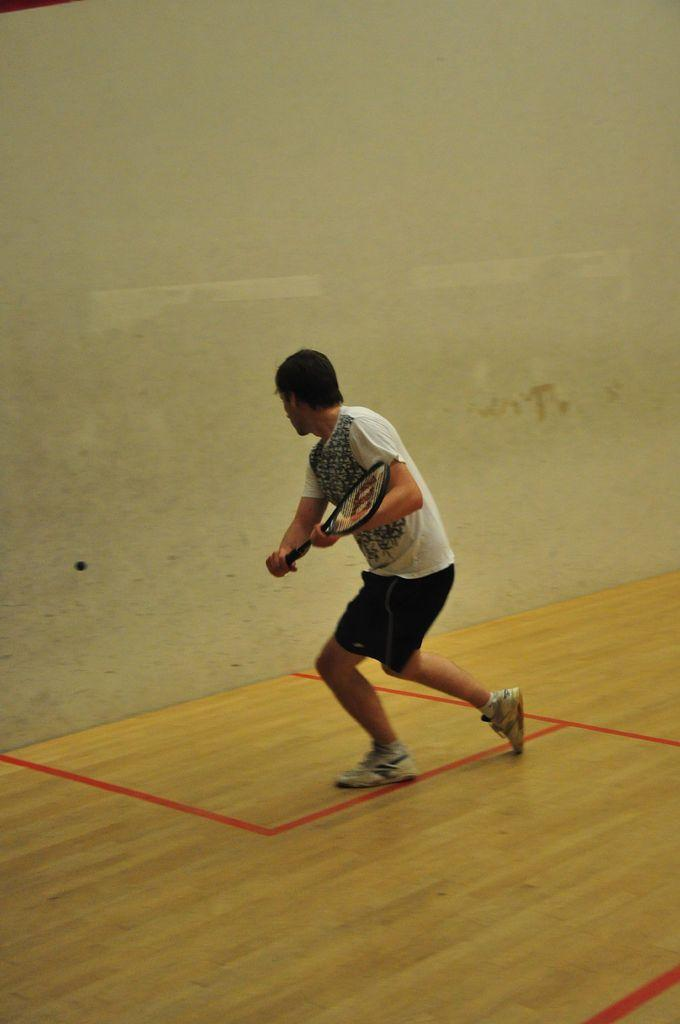What is the main subject of the picture? The main subject of the picture is a man. What is the man wearing? The man is wearing a white shirt. What object is the man holding in the picture? The man is holding a tennis racket. Are there any other tennis-related items in the picture? Yes, there is a tennis ball in the picture. What color is the kite in the picture? There is no kite present in the picture. How many legs does the man have in the picture? The man has two legs, but this question is irrelevant to the image's content, as it does not focus on the man's legs. 